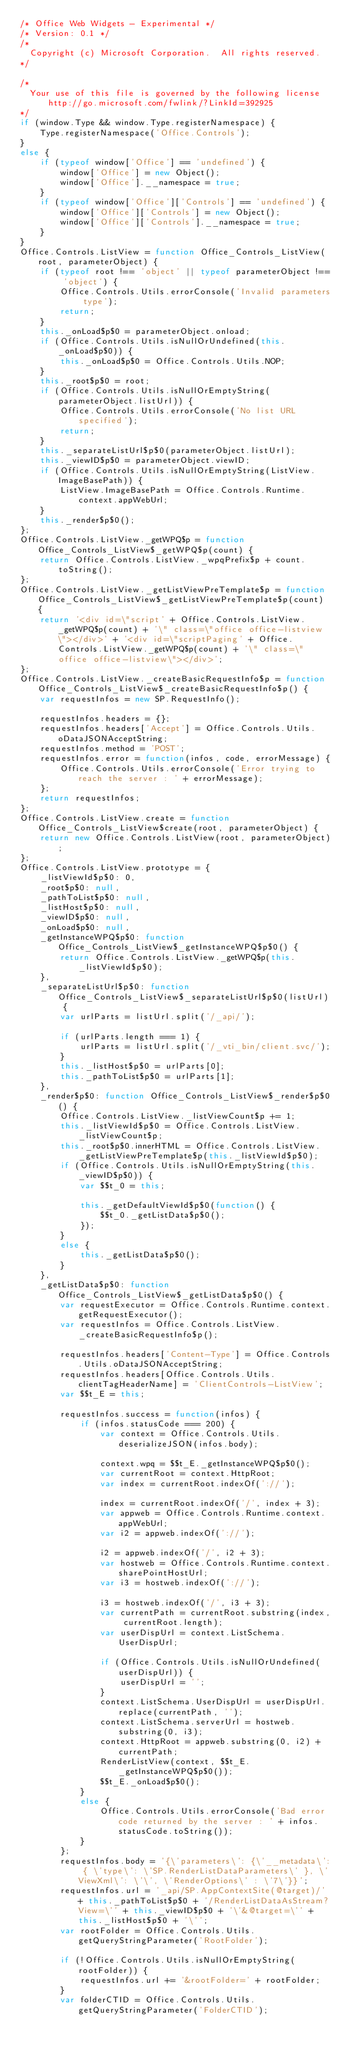<code> <loc_0><loc_0><loc_500><loc_500><_JavaScript_>/* Office Web Widgets - Experimental */
/* Version: 0.1 */
/*
	Copyright (c) Microsoft Corporation.  All rights reserved.
*/

/*
	Your use of this file is governed by the following license http://go.microsoft.com/fwlink/?LinkId=392925
*/
if (window.Type && window.Type.registerNamespace) {
    Type.registerNamespace('Office.Controls');
}
else {
    if (typeof window['Office'] == 'undefined') {
        window['Office'] = new Object();
        window['Office'].__namespace = true;
    }
    if (typeof window['Office']['Controls'] == 'undefined') {
        window['Office']['Controls'] = new Object();
        window['Office']['Controls'].__namespace = true;
    }
}
Office.Controls.ListView = function Office_Controls_ListView(root, parameterObject) {
    if (typeof root !== 'object' || typeof parameterObject !== 'object') {
        Office.Controls.Utils.errorConsole('Invalid parameters type');
        return;
    }
    this._onLoad$p$0 = parameterObject.onload;
    if (Office.Controls.Utils.isNullOrUndefined(this._onLoad$p$0)) {
        this._onLoad$p$0 = Office.Controls.Utils.NOP;
    }
    this._root$p$0 = root;
    if (Office.Controls.Utils.isNullOrEmptyString(parameterObject.listUrl)) {
        Office.Controls.Utils.errorConsole('No list URL specified');
        return;
    }
    this._separateListUrl$p$0(parameterObject.listUrl);
    this._viewID$p$0 = parameterObject.viewID;
    if (Office.Controls.Utils.isNullOrEmptyString(ListView.ImageBasePath)) {
        ListView.ImageBasePath = Office.Controls.Runtime.context.appWebUrl;
    }
    this._render$p$0();
};
Office.Controls.ListView._getWPQ$p = function Office_Controls_ListView$_getWPQ$p(count) {
    return Office.Controls.ListView._wpqPrefix$p + count.toString();
};
Office.Controls.ListView._getListViewPreTemplate$p = function Office_Controls_ListView$_getListViewPreTemplate$p(count) {
    return '<div id=\"script' + Office.Controls.ListView._getWPQ$p(count) + '\" class=\"office office-listview\"></div>' + '<div id=\"scriptPaging' + Office.Controls.ListView._getWPQ$p(count) + '\" class=\"office office-listview\"></div>';
};
Office.Controls.ListView._createBasicRequestInfo$p = function Office_Controls_ListView$_createBasicRequestInfo$p() {
    var requestInfos = new SP.RequestInfo();

    requestInfos.headers = {};
    requestInfos.headers['Accept'] = Office.Controls.Utils.oDataJSONAcceptString;
    requestInfos.method = 'POST';
    requestInfos.error = function(infos, code, errorMessage) {
        Office.Controls.Utils.errorConsole('Error trying to reach the server : ' + errorMessage);
    };
    return requestInfos;
};
Office.Controls.ListView.create = function Office_Controls_ListView$create(root, parameterObject) {
    return new Office.Controls.ListView(root, parameterObject);
};
Office.Controls.ListView.prototype = {
    _listViewId$p$0: 0,
    _root$p$0: null,
    _pathToList$p$0: null,
    _listHost$p$0: null,
    _viewID$p$0: null,
    _onLoad$p$0: null,
    _getInstanceWPQ$p$0: function Office_Controls_ListView$_getInstanceWPQ$p$0() {
        return Office.Controls.ListView._getWPQ$p(this._listViewId$p$0);
    },
    _separateListUrl$p$0: function Office_Controls_ListView$_separateListUrl$p$0(listUrl) {
        var urlParts = listUrl.split('/_api/');

        if (urlParts.length === 1) {
            urlParts = listUrl.split('/_vti_bin/client.svc/');
        }
        this._listHost$p$0 = urlParts[0];
        this._pathToList$p$0 = urlParts[1];
    },
    _render$p$0: function Office_Controls_ListView$_render$p$0() {
        Office.Controls.ListView._listViewCount$p += 1;
        this._listViewId$p$0 = Office.Controls.ListView._listViewCount$p;
        this._root$p$0.innerHTML = Office.Controls.ListView._getListViewPreTemplate$p(this._listViewId$p$0);
        if (Office.Controls.Utils.isNullOrEmptyString(this._viewID$p$0)) {
            var $$t_0 = this;

            this._getDefaultViewId$p$0(function() {
                $$t_0._getListData$p$0();
            });
        }
        else {
            this._getListData$p$0();
        }
    },
    _getListData$p$0: function Office_Controls_ListView$_getListData$p$0() {
        var requestExecutor = Office.Controls.Runtime.context.getRequestExecutor();
        var requestInfos = Office.Controls.ListView._createBasicRequestInfo$p();

        requestInfos.headers['Content-Type'] = Office.Controls.Utils.oDataJSONAcceptString;
        requestInfos.headers[Office.Controls.Utils.clientTagHeaderName] = 'ClientControls-ListView';
        var $$t_E = this;

        requestInfos.success = function(infos) {
            if (infos.statusCode === 200) {
                var context = Office.Controls.Utils.deserializeJSON(infos.body);

                context.wpq = $$t_E._getInstanceWPQ$p$0();
                var currentRoot = context.HttpRoot;
                var index = currentRoot.indexOf('://');

                index = currentRoot.indexOf('/', index + 3);
                var appweb = Office.Controls.Runtime.context.appWebUrl;
                var i2 = appweb.indexOf('://');

                i2 = appweb.indexOf('/', i2 + 3);
                var hostweb = Office.Controls.Runtime.context.sharePointHostUrl;
                var i3 = hostweb.indexOf('://');

                i3 = hostweb.indexOf('/', i3 + 3);
                var currentPath = currentRoot.substring(index, currentRoot.length);
                var userDispUrl = context.ListSchema.UserDispUrl;

                if (Office.Controls.Utils.isNullOrUndefined(userDispUrl)) {
                    userDispUrl = '';
                }
                context.ListSchema.UserDispUrl = userDispUrl.replace(currentPath, '');
                context.ListSchema.serverUrl = hostweb.substring(0, i3);
                context.HttpRoot = appweb.substring(0, i2) + currentPath;
                RenderListView(context, $$t_E._getInstanceWPQ$p$0());
                $$t_E._onLoad$p$0();
            }
            else {
                Office.Controls.Utils.errorConsole('Bad error code returned by the server : ' + infos.statusCode.toString());
            }
        };
        requestInfos.body = '{\'parameters\': {\'__metadata\': { \'type\': \'SP.RenderListDataParameters\' }, \'ViewXml\': \'\', \'RenderOptions\' : \'7\'}}';
        requestInfos.url = '_api/SP.AppContextSite(@target)/' + this._pathToList$p$0 + '/RenderListDataAsStream?View=\'' + this._viewID$p$0 + '\'&@target=\'' + this._listHost$p$0 + '\'';
        var rootFolder = Office.Controls.Utils.getQueryStringParameter('RootFolder');

        if (!Office.Controls.Utils.isNullOrEmptyString(rootFolder)) {
            requestInfos.url += '&rootFolder=' + rootFolder;
        }
        var folderCTID = Office.Controls.Utils.getQueryStringParameter('FolderCTID');
</code> 